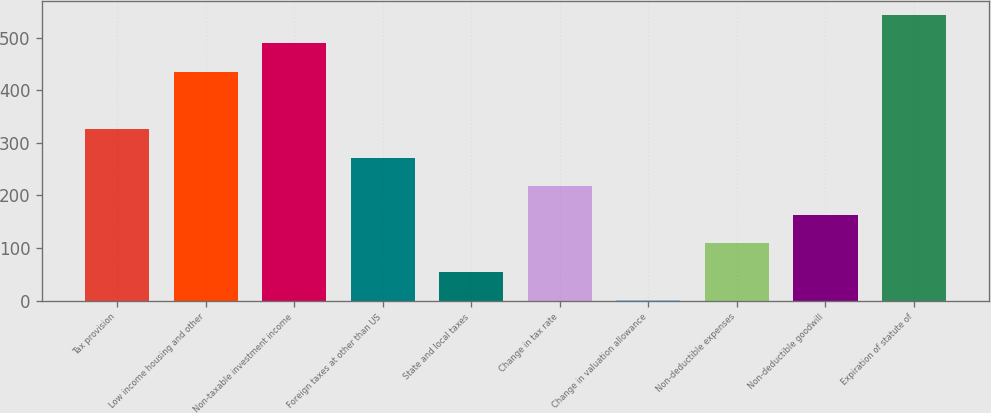Convert chart to OTSL. <chart><loc_0><loc_0><loc_500><loc_500><bar_chart><fcel>Tax provision<fcel>Low income housing and other<fcel>Non-taxable investment income<fcel>Foreign taxes at other than US<fcel>State and local taxes<fcel>Change in tax rate<fcel>Change in valuation allowance<fcel>Non-deductible expenses<fcel>Non-deductible goodwill<fcel>Expiration of statute of<nl><fcel>326.17<fcel>434.59<fcel>488.8<fcel>271.96<fcel>55.12<fcel>217.75<fcel>0.91<fcel>109.33<fcel>163.54<fcel>543.01<nl></chart> 